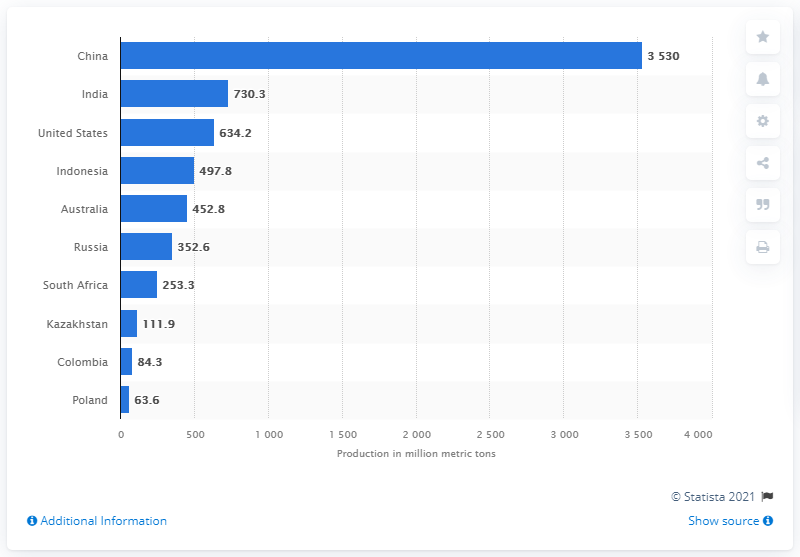Identify some key points in this picture. China is the leading producer of hard coal worldwide. In 2018, China produced 35,300 metric tons of hard coal. 